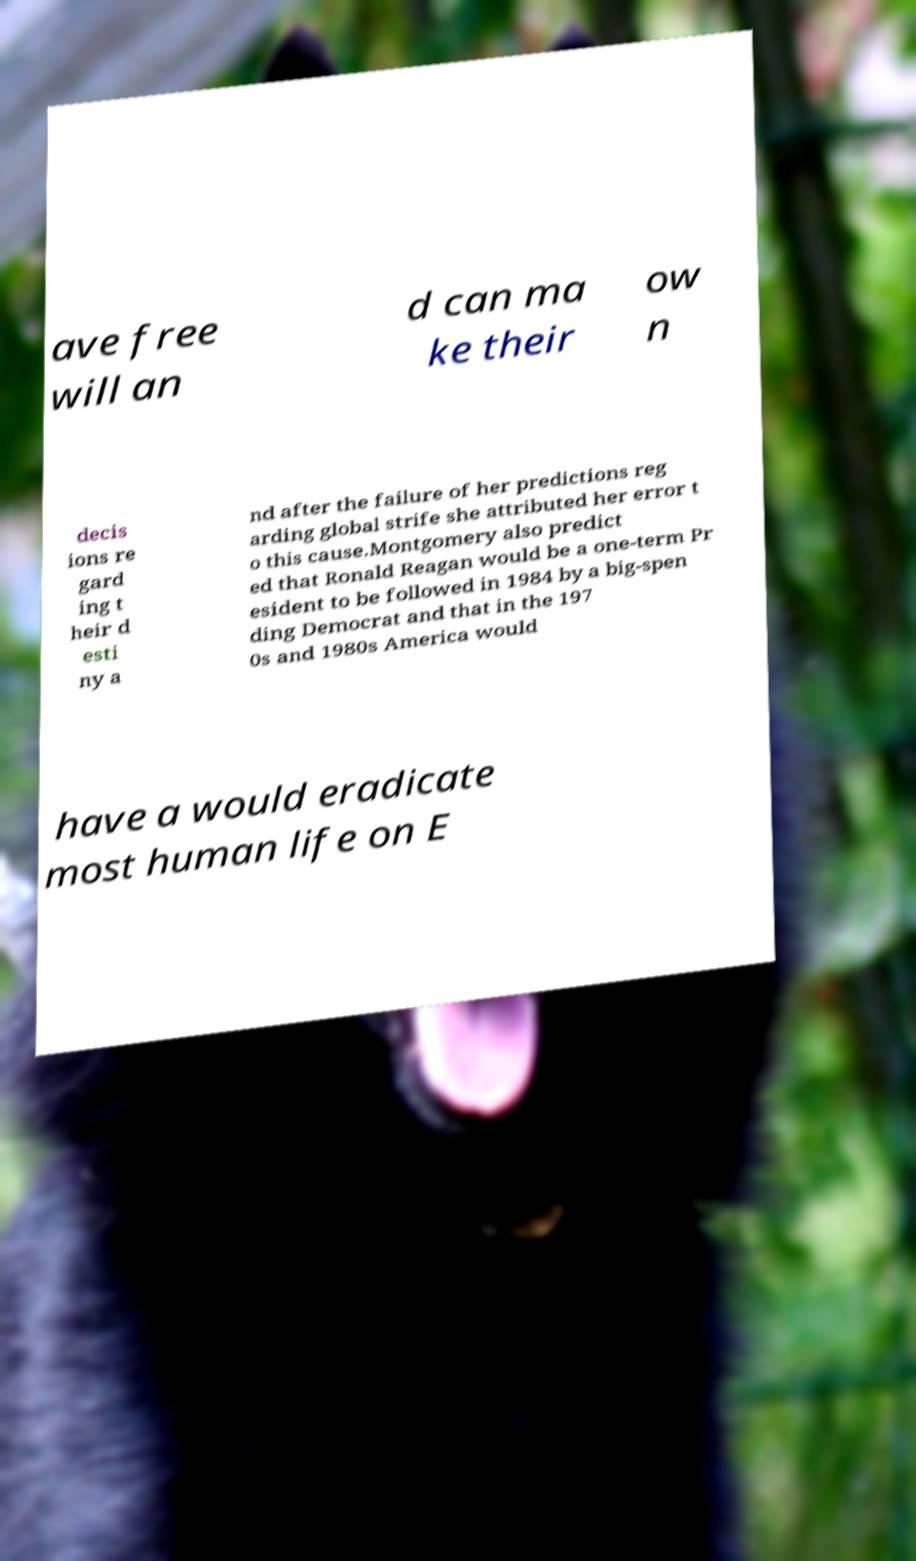Please identify and transcribe the text found in this image. ave free will an d can ma ke their ow n decis ions re gard ing t heir d esti ny a nd after the failure of her predictions reg arding global strife she attributed her error t o this cause.Montgomery also predict ed that Ronald Reagan would be a one-term Pr esident to be followed in 1984 by a big-spen ding Democrat and that in the 197 0s and 1980s America would have a would eradicate most human life on E 